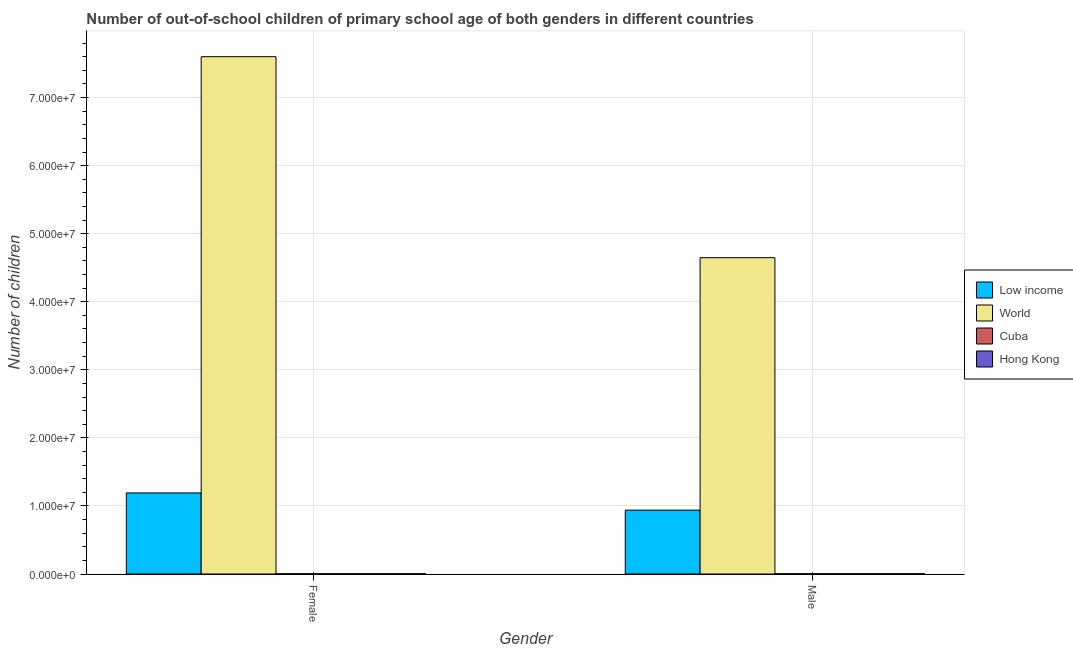How many different coloured bars are there?
Offer a terse response. 4. How many groups of bars are there?
Make the answer very short. 2. Are the number of bars per tick equal to the number of legend labels?
Your answer should be very brief. Yes. How many bars are there on the 2nd tick from the left?
Keep it short and to the point. 4. What is the label of the 2nd group of bars from the left?
Your answer should be very brief. Male. What is the number of female out-of-school students in Hong Kong?
Make the answer very short. 3.99e+04. Across all countries, what is the maximum number of male out-of-school students?
Provide a succinct answer. 4.65e+07. Across all countries, what is the minimum number of male out-of-school students?
Keep it short and to the point. 3.90e+04. In which country was the number of male out-of-school students minimum?
Ensure brevity in your answer.  Hong Kong. What is the total number of male out-of-school students in the graph?
Your response must be concise. 5.59e+07. What is the difference between the number of female out-of-school students in World and that in Cuba?
Your answer should be compact. 7.60e+07. What is the difference between the number of female out-of-school students in Hong Kong and the number of male out-of-school students in World?
Your answer should be very brief. -4.64e+07. What is the average number of male out-of-school students per country?
Offer a terse response. 1.40e+07. What is the difference between the number of female out-of-school students and number of male out-of-school students in World?
Keep it short and to the point. 2.95e+07. In how many countries, is the number of male out-of-school students greater than 18000000 ?
Ensure brevity in your answer.  1. What is the ratio of the number of female out-of-school students in Hong Kong to that in Low income?
Give a very brief answer. 0. Is the number of male out-of-school students in Hong Kong less than that in Cuba?
Give a very brief answer. Yes. What does the 3rd bar from the left in Female represents?
Provide a succinct answer. Cuba. What does the 1st bar from the right in Male represents?
Offer a very short reply. Hong Kong. Are all the bars in the graph horizontal?
Make the answer very short. No. Are the values on the major ticks of Y-axis written in scientific E-notation?
Your answer should be very brief. Yes. Does the graph contain grids?
Give a very brief answer. Yes. How are the legend labels stacked?
Offer a terse response. Vertical. What is the title of the graph?
Provide a succinct answer. Number of out-of-school children of primary school age of both genders in different countries. Does "Tanzania" appear as one of the legend labels in the graph?
Offer a very short reply. No. What is the label or title of the Y-axis?
Provide a short and direct response. Number of children. What is the Number of children of Low income in Female?
Give a very brief answer. 1.19e+07. What is the Number of children of World in Female?
Offer a terse response. 7.60e+07. What is the Number of children in Cuba in Female?
Offer a very short reply. 3.59e+04. What is the Number of children in Hong Kong in Female?
Your answer should be compact. 3.99e+04. What is the Number of children in Low income in Male?
Ensure brevity in your answer.  9.38e+06. What is the Number of children of World in Male?
Make the answer very short. 4.65e+07. What is the Number of children in Cuba in Male?
Keep it short and to the point. 4.46e+04. What is the Number of children in Hong Kong in Male?
Offer a terse response. 3.90e+04. Across all Gender, what is the maximum Number of children in Low income?
Provide a succinct answer. 1.19e+07. Across all Gender, what is the maximum Number of children in World?
Ensure brevity in your answer.  7.60e+07. Across all Gender, what is the maximum Number of children of Cuba?
Give a very brief answer. 4.46e+04. Across all Gender, what is the maximum Number of children of Hong Kong?
Give a very brief answer. 3.99e+04. Across all Gender, what is the minimum Number of children of Low income?
Make the answer very short. 9.38e+06. Across all Gender, what is the minimum Number of children in World?
Your answer should be compact. 4.65e+07. Across all Gender, what is the minimum Number of children in Cuba?
Your response must be concise. 3.59e+04. Across all Gender, what is the minimum Number of children of Hong Kong?
Give a very brief answer. 3.90e+04. What is the total Number of children in Low income in the graph?
Offer a terse response. 2.13e+07. What is the total Number of children of World in the graph?
Offer a very short reply. 1.22e+08. What is the total Number of children of Cuba in the graph?
Your response must be concise. 8.04e+04. What is the total Number of children of Hong Kong in the graph?
Your answer should be very brief. 7.89e+04. What is the difference between the Number of children of Low income in Female and that in Male?
Give a very brief answer. 2.53e+06. What is the difference between the Number of children in World in Female and that in Male?
Your response must be concise. 2.95e+07. What is the difference between the Number of children in Cuba in Female and that in Male?
Offer a very short reply. -8683. What is the difference between the Number of children in Hong Kong in Female and that in Male?
Offer a terse response. 878. What is the difference between the Number of children of Low income in Female and the Number of children of World in Male?
Provide a short and direct response. -3.46e+07. What is the difference between the Number of children in Low income in Female and the Number of children in Cuba in Male?
Provide a short and direct response. 1.19e+07. What is the difference between the Number of children of Low income in Female and the Number of children of Hong Kong in Male?
Offer a very short reply. 1.19e+07. What is the difference between the Number of children in World in Female and the Number of children in Cuba in Male?
Offer a very short reply. 7.60e+07. What is the difference between the Number of children in World in Female and the Number of children in Hong Kong in Male?
Your answer should be compact. 7.60e+07. What is the difference between the Number of children of Cuba in Female and the Number of children of Hong Kong in Male?
Your response must be concise. -3144. What is the average Number of children in Low income per Gender?
Ensure brevity in your answer.  1.06e+07. What is the average Number of children in World per Gender?
Keep it short and to the point. 6.12e+07. What is the average Number of children of Cuba per Gender?
Provide a short and direct response. 4.02e+04. What is the average Number of children in Hong Kong per Gender?
Provide a short and direct response. 3.95e+04. What is the difference between the Number of children in Low income and Number of children in World in Female?
Make the answer very short. -6.41e+07. What is the difference between the Number of children in Low income and Number of children in Cuba in Female?
Ensure brevity in your answer.  1.19e+07. What is the difference between the Number of children in Low income and Number of children in Hong Kong in Female?
Make the answer very short. 1.19e+07. What is the difference between the Number of children in World and Number of children in Cuba in Female?
Make the answer very short. 7.60e+07. What is the difference between the Number of children of World and Number of children of Hong Kong in Female?
Ensure brevity in your answer.  7.60e+07. What is the difference between the Number of children in Cuba and Number of children in Hong Kong in Female?
Provide a succinct answer. -4022. What is the difference between the Number of children in Low income and Number of children in World in Male?
Provide a succinct answer. -3.71e+07. What is the difference between the Number of children in Low income and Number of children in Cuba in Male?
Give a very brief answer. 9.34e+06. What is the difference between the Number of children of Low income and Number of children of Hong Kong in Male?
Ensure brevity in your answer.  9.34e+06. What is the difference between the Number of children in World and Number of children in Cuba in Male?
Provide a short and direct response. 4.64e+07. What is the difference between the Number of children in World and Number of children in Hong Kong in Male?
Ensure brevity in your answer.  4.64e+07. What is the difference between the Number of children of Cuba and Number of children of Hong Kong in Male?
Your response must be concise. 5539. What is the ratio of the Number of children in Low income in Female to that in Male?
Make the answer very short. 1.27. What is the ratio of the Number of children of World in Female to that in Male?
Offer a very short reply. 1.64. What is the ratio of the Number of children of Cuba in Female to that in Male?
Your response must be concise. 0.81. What is the ratio of the Number of children of Hong Kong in Female to that in Male?
Ensure brevity in your answer.  1.02. What is the difference between the highest and the second highest Number of children of Low income?
Offer a terse response. 2.53e+06. What is the difference between the highest and the second highest Number of children in World?
Give a very brief answer. 2.95e+07. What is the difference between the highest and the second highest Number of children in Cuba?
Provide a short and direct response. 8683. What is the difference between the highest and the second highest Number of children of Hong Kong?
Keep it short and to the point. 878. What is the difference between the highest and the lowest Number of children in Low income?
Your answer should be very brief. 2.53e+06. What is the difference between the highest and the lowest Number of children of World?
Make the answer very short. 2.95e+07. What is the difference between the highest and the lowest Number of children of Cuba?
Keep it short and to the point. 8683. What is the difference between the highest and the lowest Number of children in Hong Kong?
Your answer should be very brief. 878. 